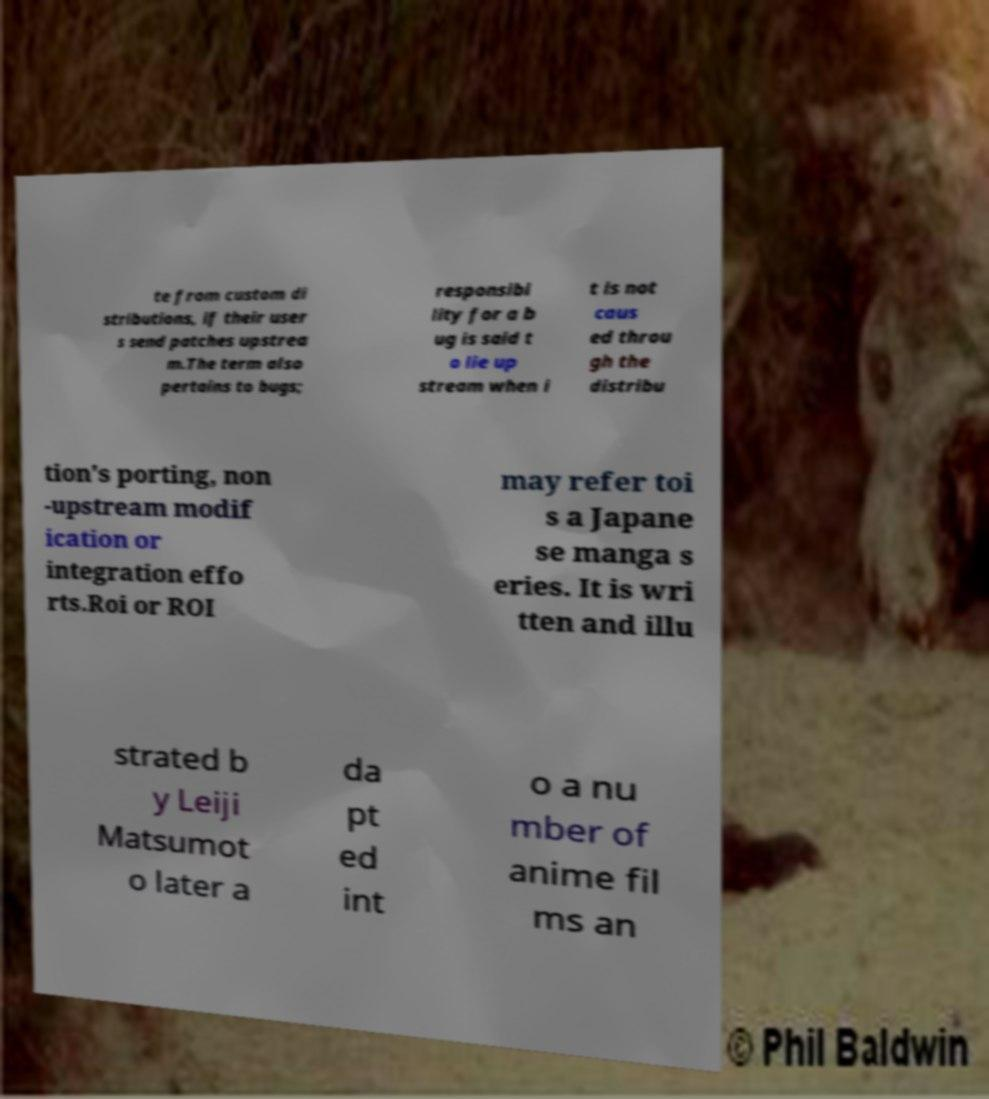I need the written content from this picture converted into text. Can you do that? te from custom di stributions, if their user s send patches upstrea m.The term also pertains to bugs; responsibi lity for a b ug is said t o lie up stream when i t is not caus ed throu gh the distribu tion's porting, non -upstream modif ication or integration effo rts.Roi or ROI may refer toi s a Japane se manga s eries. It is wri tten and illu strated b y Leiji Matsumot o later a da pt ed int o a nu mber of anime fil ms an 